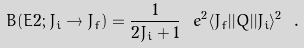<formula> <loc_0><loc_0><loc_500><loc_500>B ( E 2 ; J _ { i } \rightarrow J _ { f } ) = \frac { 1 } { 2 J _ { i } + 1 } \ e ^ { 2 } \langle J _ { f } | | Q | | J _ { i } \rangle ^ { 2 } \ .</formula> 